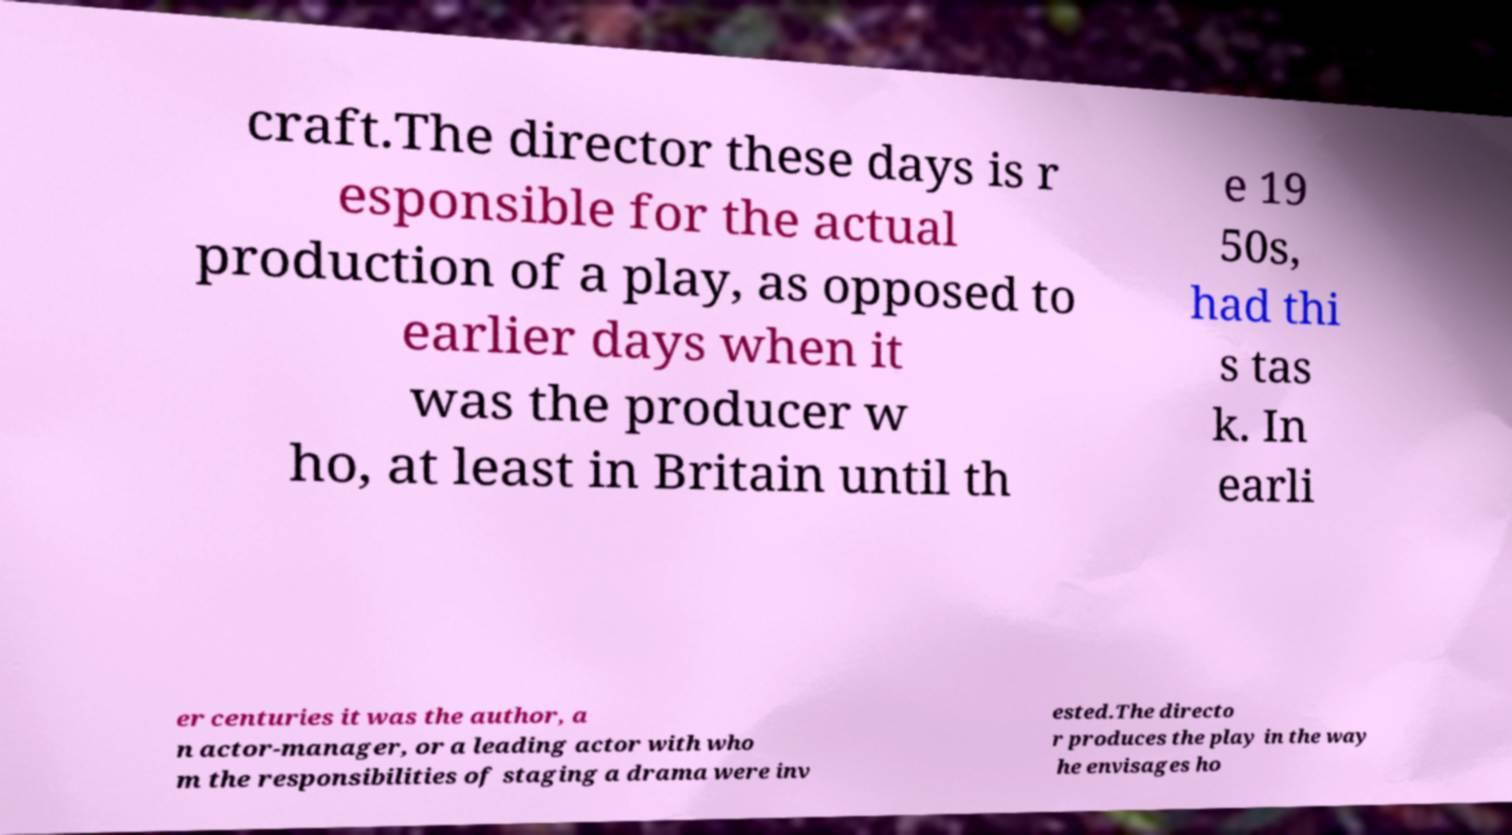Could you extract and type out the text from this image? craft.The director these days is r esponsible for the actual production of a play, as opposed to earlier days when it was the producer w ho, at least in Britain until th e 19 50s, had thi s tas k. In earli er centuries it was the author, a n actor-manager, or a leading actor with who m the responsibilities of staging a drama were inv ested.The directo r produces the play in the way he envisages ho 